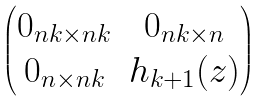Convert formula to latex. <formula><loc_0><loc_0><loc_500><loc_500>\begin{pmatrix} 0 _ { n k \times n k } & 0 _ { n k \times n } \\ 0 _ { n \times n k } & h _ { k + 1 } ( z ) \\ \end{pmatrix}</formula> 